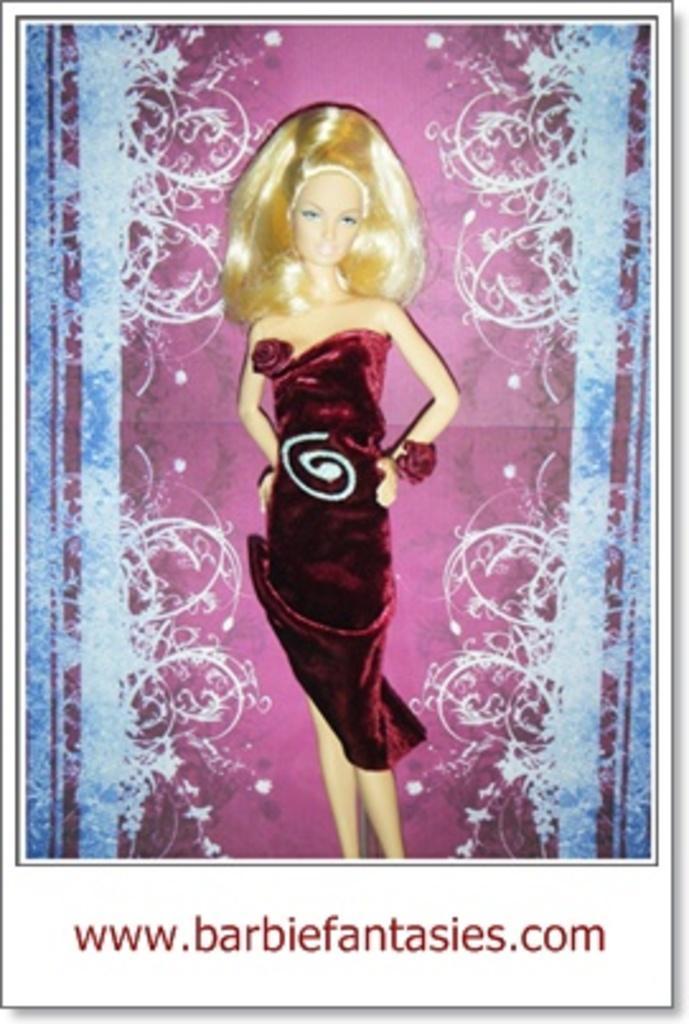Could you give a brief overview of what you see in this image? This image consists of a photograph. Here I can see a barbie in a frock. At the bottom I can see some text in red color. 